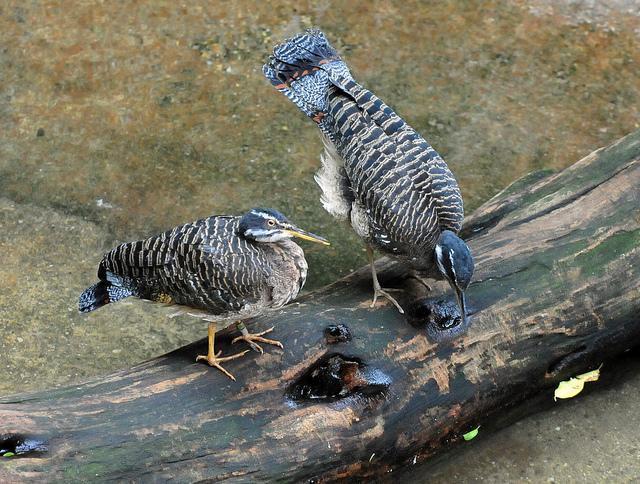How many birds can be seen?
Give a very brief answer. 2. How many red cars can be seen to the right of the bus?
Give a very brief answer. 0. 